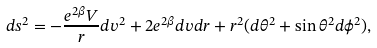Convert formula to latex. <formula><loc_0><loc_0><loc_500><loc_500>d s ^ { 2 } = - \frac { e ^ { 2 \beta } V } { r } d v ^ { 2 } + 2 e ^ { 2 \beta } d v d r + r ^ { 2 } ( d \theta ^ { 2 } + \sin \theta ^ { 2 } d \phi ^ { 2 } ) ,</formula> 